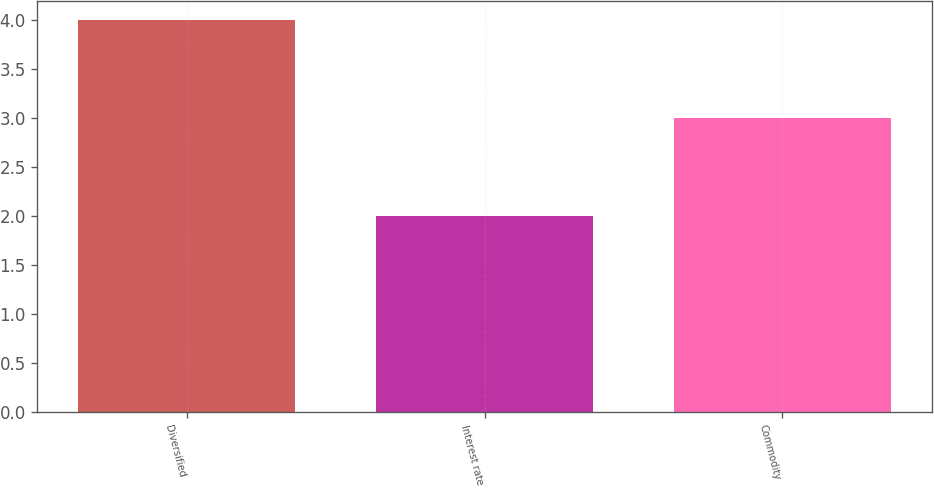Convert chart to OTSL. <chart><loc_0><loc_0><loc_500><loc_500><bar_chart><fcel>Diversified<fcel>Interest rate<fcel>Commodity<nl><fcel>4<fcel>2<fcel>3<nl></chart> 